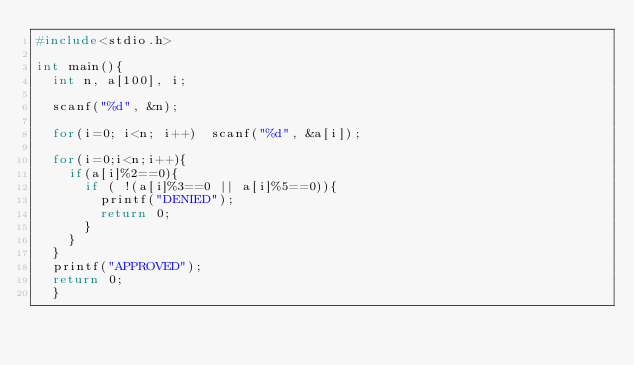Convert code to text. <code><loc_0><loc_0><loc_500><loc_500><_C_>#include<stdio.h>

int main(){
	int n, a[100], i;
	
	scanf("%d", &n);
	
	for(i=0; i<n; i++)	scanf("%d", &a[i]);
	
	for(i=0;i<n;i++){
		if(a[i]%2==0){
			if ( !(a[i]%3==0 || a[i]%5==0)){
				printf("DENIED");
				return 0;
			}
		}
	}
	printf("APPROVED");
	return 0;
	}</code> 